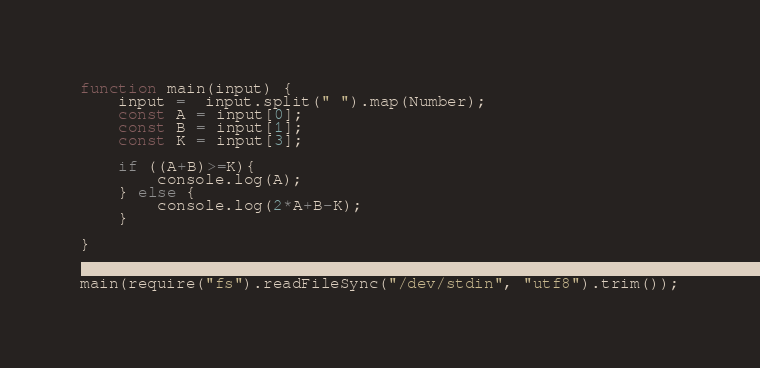Convert code to text. <code><loc_0><loc_0><loc_500><loc_500><_JavaScript_>function main(input) {
	input =  input.split(" ").map(Number);
	const A = input[0];
	const B = input[1];
	const K = input[3];

	if ((A+B)>=K){
	    console.log(A);
	} else {
	    console.log(2*A+B-K);
	}

}


main(require("fs").readFileSync("/dev/stdin", "utf8").trim());</code> 